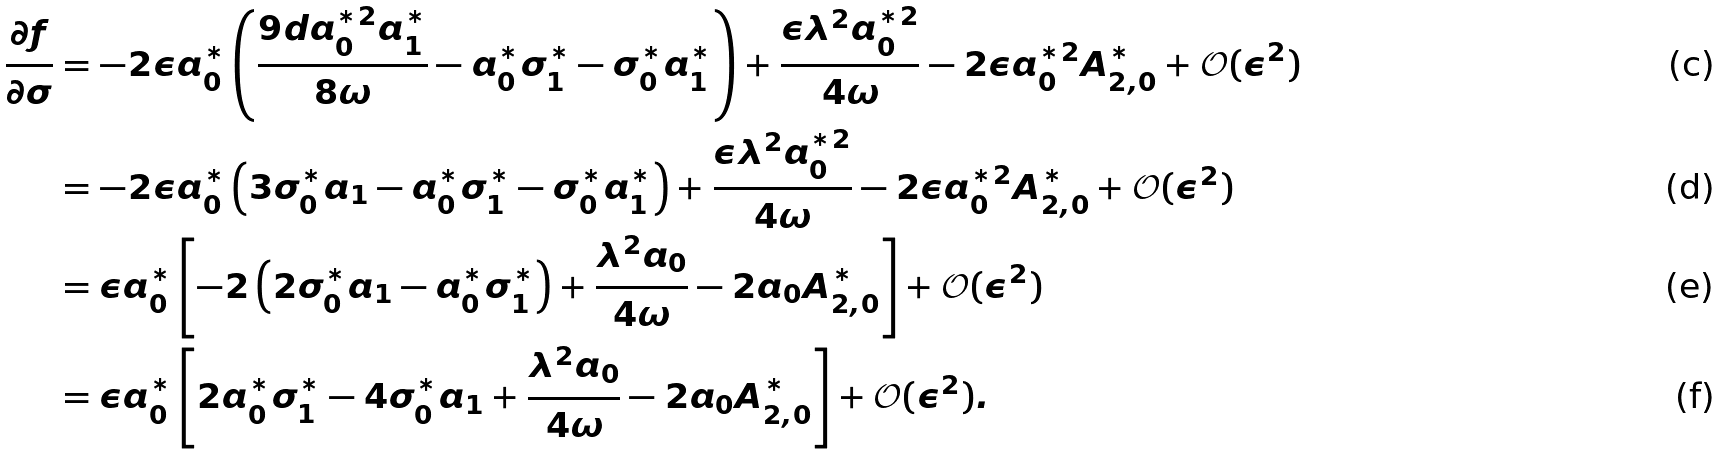<formula> <loc_0><loc_0><loc_500><loc_500>\frac { \partial f } { \partial \sigma } & = - 2 \epsilon a _ { 0 } ^ { * } \left ( \frac { 9 d a _ { 0 } ^ { * 2 } a _ { 1 } ^ { * } } { 8 \omega } - a _ { 0 } ^ { * } \sigma _ { 1 } ^ { * } - \sigma _ { 0 } ^ { * } a _ { 1 } ^ { * } \right ) + \frac { \epsilon \lambda ^ { 2 } a _ { 0 } ^ { * 2 } } { 4 \omega } - 2 \epsilon a _ { 0 } ^ { * 2 } A _ { 2 , 0 } ^ { * } + \mathcal { O } ( \epsilon ^ { 2 } ) \\ & = - 2 \epsilon a _ { 0 } ^ { * } \left ( 3 \sigma _ { 0 } ^ { * } a _ { 1 } - a _ { 0 } ^ { * } \sigma _ { 1 } ^ { * } - \sigma _ { 0 } ^ { * } a _ { 1 } ^ { * } \right ) + \frac { \epsilon \lambda ^ { 2 } a _ { 0 } ^ { * 2 } } { 4 \omega } - 2 \epsilon a _ { 0 } ^ { * 2 } A _ { 2 , 0 } ^ { * } + \mathcal { O } ( \epsilon ^ { 2 } ) \\ & = \epsilon a _ { 0 } ^ { * } \left [ - 2 \left ( 2 \sigma _ { 0 } ^ { * } a _ { 1 } - a _ { 0 } ^ { * } \sigma _ { 1 } ^ { * } \right ) + \frac { \lambda ^ { 2 } a _ { 0 } } { 4 \omega } - 2 a _ { 0 } A _ { 2 , 0 } ^ { * } \right ] + \mathcal { O } ( \epsilon ^ { 2 } ) \\ & = \epsilon a _ { 0 } ^ { * } \left [ 2 a _ { 0 } ^ { * } \sigma _ { 1 } ^ { * } - 4 \sigma _ { 0 } ^ { * } a _ { 1 } + \frac { \lambda ^ { 2 } a _ { 0 } } { 4 \omega } - 2 a _ { 0 } A _ { 2 , 0 } ^ { * } \right ] + \mathcal { O } ( \epsilon ^ { 2 } ) .</formula> 